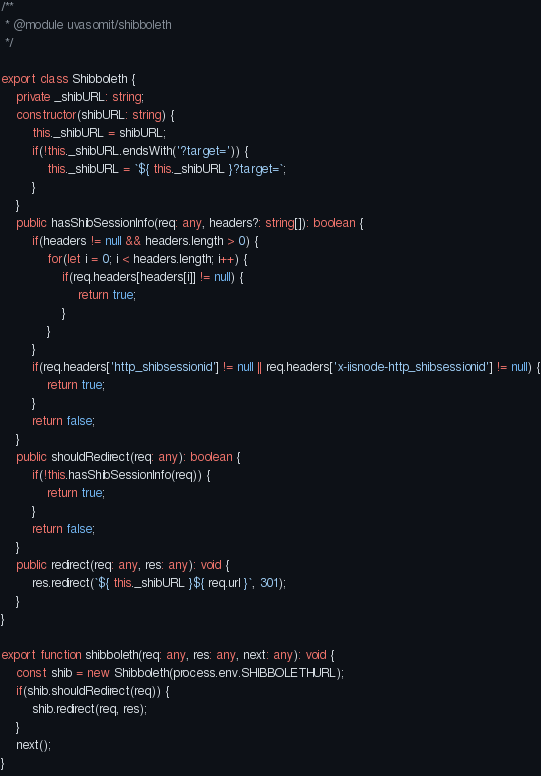Convert code to text. <code><loc_0><loc_0><loc_500><loc_500><_TypeScript_>/**
 * @module uvasomit/shibboleth
 */

export class Shibboleth {
    private _shibURL: string;
    constructor(shibURL: string) {
        this._shibURL = shibURL;
        if(!this._shibURL.endsWith('?target=')) {
            this._shibURL = `${ this._shibURL }?target=`;
        }
    }
    public hasShibSessionInfo(req: any, headers?: string[]): boolean {
        if(headers != null && headers.length > 0) {
            for(let i = 0; i < headers.length; i++) {
                if(req.headers[headers[i]] != null) {
                    return true;
                }
            }
        }
        if(req.headers['http_shibsessionid'] != null || req.headers['x-iisnode-http_shibsessionid'] != null) {
            return true;
        }
        return false;
    }
    public shouldRedirect(req: any): boolean {
        if(!this.hasShibSessionInfo(req)) {
            return true;
        }
        return false;
    }
    public redirect(req: any, res: any): void {
        res.redirect(`${ this._shibURL }${ req.url }`, 301);
    }
}

export function shibboleth(req: any, res: any, next: any): void {
    const shib = new Shibboleth(process.env.SHIBBOLETHURL);
    if(shib.shouldRedirect(req)) {
        shib.redirect(req, res);
    }
    next();
}
</code> 